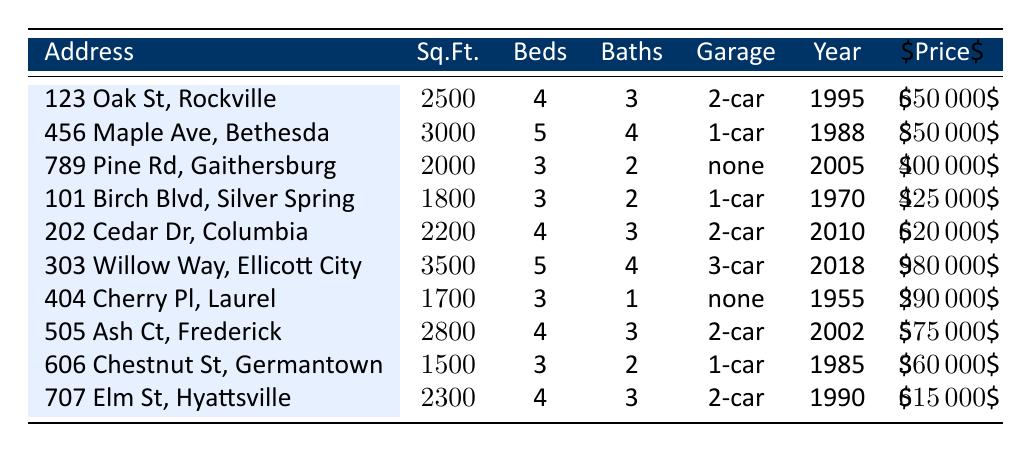What is the sale price of the house at 123 Oak St, Rockville? The table lists the sale price next to the address. For 123 Oak St, Rockville, the sale price is $650,000.
Answer: $650,000 How many bedrooms does the property at 303 Willow Way, Ellicott City have? The number of bedrooms for each address is shown in the table. The property at 303 Willow Way has 5 bedrooms.
Answer: 5 Which house has the largest square footage? All addresses are listed with their respective square footage. By comparing these values, the largest square footage is at 303 Willow Way with 3,500 sq.ft.
Answer: 3,500 sq.ft How many properties were built after the year 2000? By counting the entries where the "Year Built" is greater than 2000 (2010, 2018), there are 3 properties.
Answer: 3 What is the average sale price of homes with 4 bedrooms? The sale prices for homes with 4 bedrooms are $650,000, $850,000, $620,000, $575,000, and $615,000. The sum is $3,610,000 for 5 homes. The average price is $3,610,000 ÷ 5 = $722,000.
Answer: $722,000 Does the home at 404 Cherry Pl, Laurel have a garage? The table indicates whether each property has a garage. The property at 404 Cherry Pl has no garage.
Answer: No What is the difference in sale price between the most expensive and least expensive homes? The highest sale price is $980,000 for the house at 303 Willow Way, and the lowest is $290,000 for the house at 404 Cherry Pl. The difference is $980,000 - $290,000 = $690,000.
Answer: $690,000 What percentage of homes listed have a 2-car garage? There are 10 properties listed. The properties with a 2-car garage are 123 Oak St, 202 Cedar Dr, 505 Ash Ct, and 707 Elm St, which is 4 homes. The percentage is (4/10) * 100 = 40%.
Answer: 40% What is the median square footage of homes built before 1990? The homes built before 1990 are 101 Birch Blvd (1,800), 404 Cherry Pl (1,700), and 606 Chestnut St (1,500). Arranging these gives 1,500, 1,700, 1,800. The median (middle value) for 3 entries is 1,700 sq.ft.
Answer: 1,700 sq.ft Which neighborhood has the highest average sale price? The average sale price per neighborhood must be calculated. For Rockville Town Center, the average is $650,000. For Bethesda Forest, it's $850,000. For Kentlands, it's $400,000, and so on. The highest average sale price is in Bethesda Forest at $850,000.
Answer: Bethesda Forest 